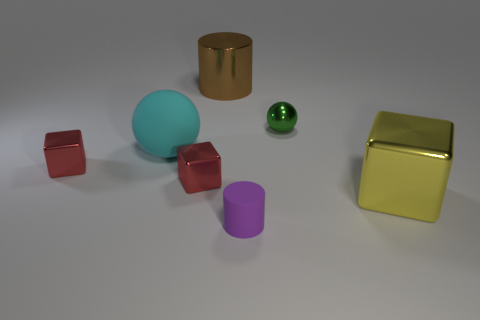Add 1 tiny green matte spheres. How many objects exist? 8 Subtract all cylinders. How many objects are left? 5 Add 5 small green metallic objects. How many small green metallic objects exist? 6 Subtract 0 cyan blocks. How many objects are left? 7 Subtract all tiny gray rubber cubes. Subtract all large brown objects. How many objects are left? 6 Add 2 cylinders. How many cylinders are left? 4 